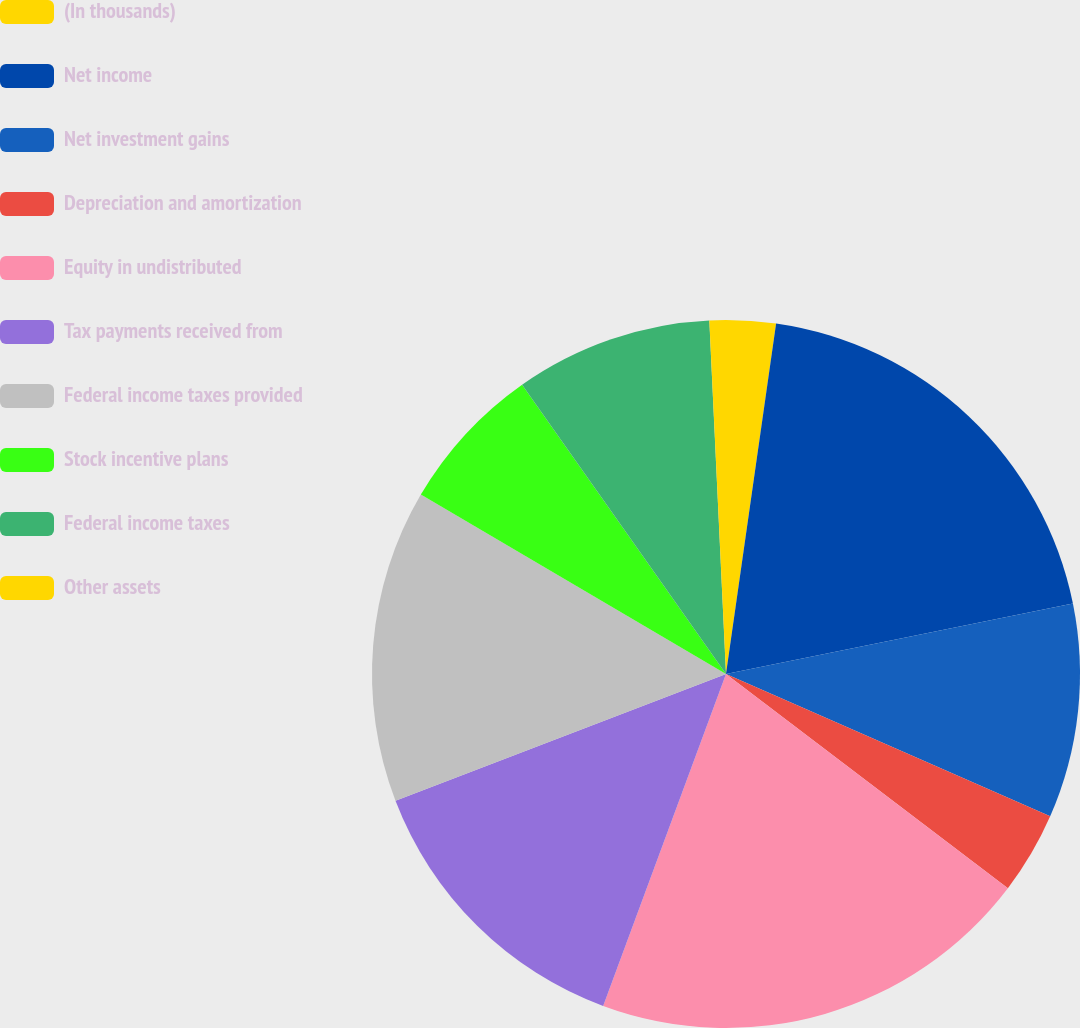Convert chart to OTSL. <chart><loc_0><loc_0><loc_500><loc_500><pie_chart><fcel>(In thousands)<fcel>Net income<fcel>Net investment gains<fcel>Depreciation and amortization<fcel>Equity in undistributed<fcel>Tax payments received from<fcel>Federal income taxes provided<fcel>Stock incentive plans<fcel>Federal income taxes<fcel>Other assets<nl><fcel>2.26%<fcel>19.55%<fcel>9.77%<fcel>3.76%<fcel>20.3%<fcel>13.53%<fcel>14.29%<fcel>6.77%<fcel>9.02%<fcel>0.75%<nl></chart> 